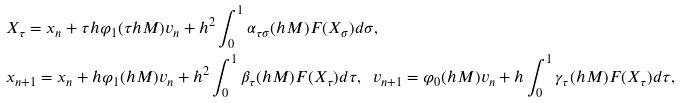Convert formula to latex. <formula><loc_0><loc_0><loc_500><loc_500>& X _ { \tau } = x _ { n } + \tau h \varphi _ { 1 } ( \tau h M ) v _ { n } + h ^ { 2 } \int _ { 0 } ^ { 1 } { \alpha } _ { \tau \sigma } ( h M ) F ( X _ { \sigma } ) d \sigma , \\ & x _ { n + 1 } = x _ { n } + h \varphi _ { 1 } ( h M ) v _ { n } + h ^ { 2 } \int _ { 0 } ^ { 1 } \beta _ { \tau } ( h M ) F ( X _ { \tau } ) d \tau , \ \ v _ { n + 1 } = \varphi _ { 0 } ( h M ) v _ { n } + h \int _ { 0 } ^ { 1 } \gamma _ { \tau } ( h M ) F ( X _ { \tau } ) d \tau ,</formula> 